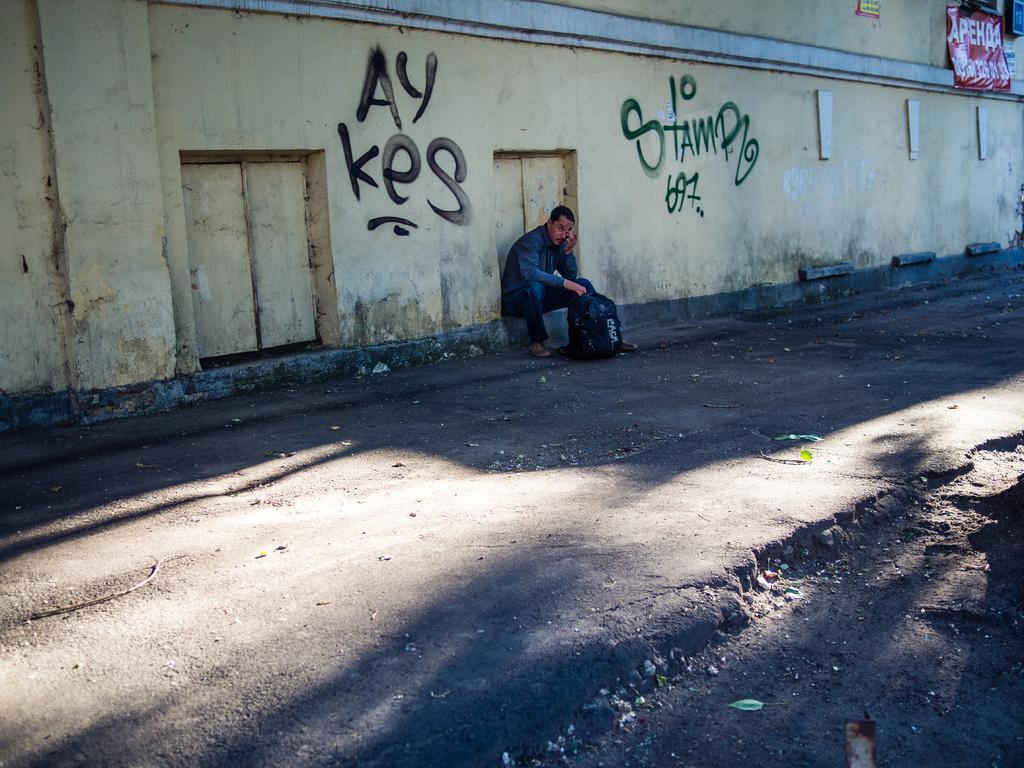Describe this image in one or two sentences. In this image there is a man sitting on the wall by holding the black colour bag. There is a road in front of him on which there are stones. In the background there is a wall on which there is painting. On the right side top corner there is a banner to the wall. 